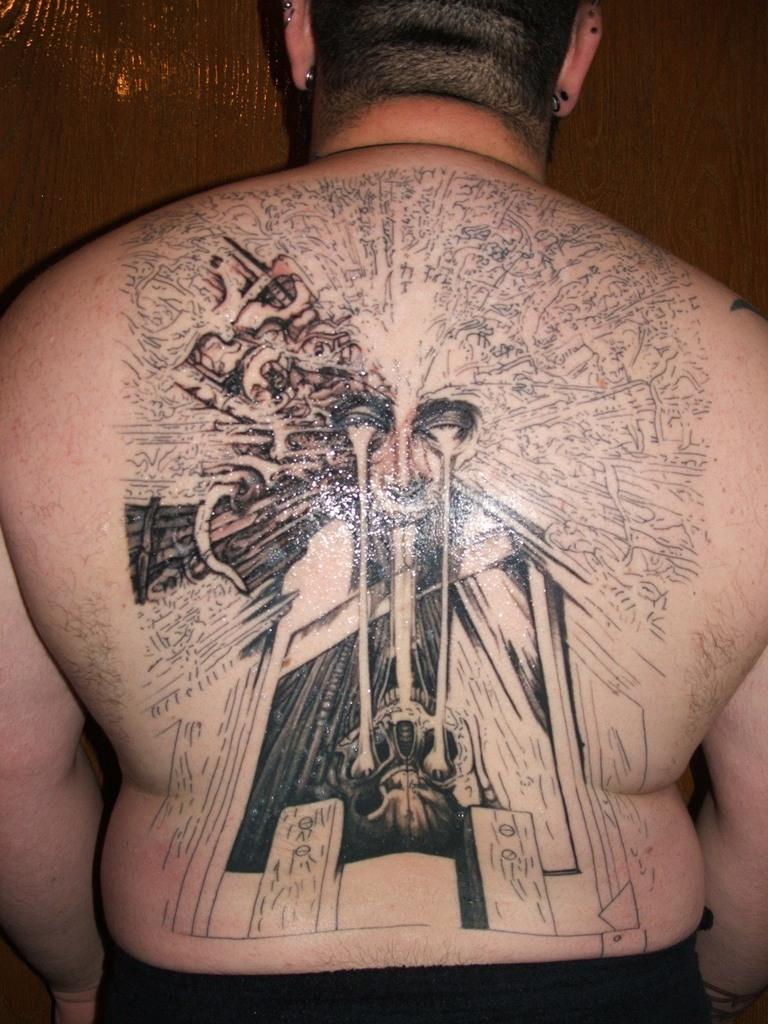What is visible on the person's body in the image? There is a tattoo on the person's body in the image. What type of material is used for the wall in the background? The wall in the background is made of wood. Can you see a kitten playing with a tray in the image? No, there is no kitten or tray present in the image. 